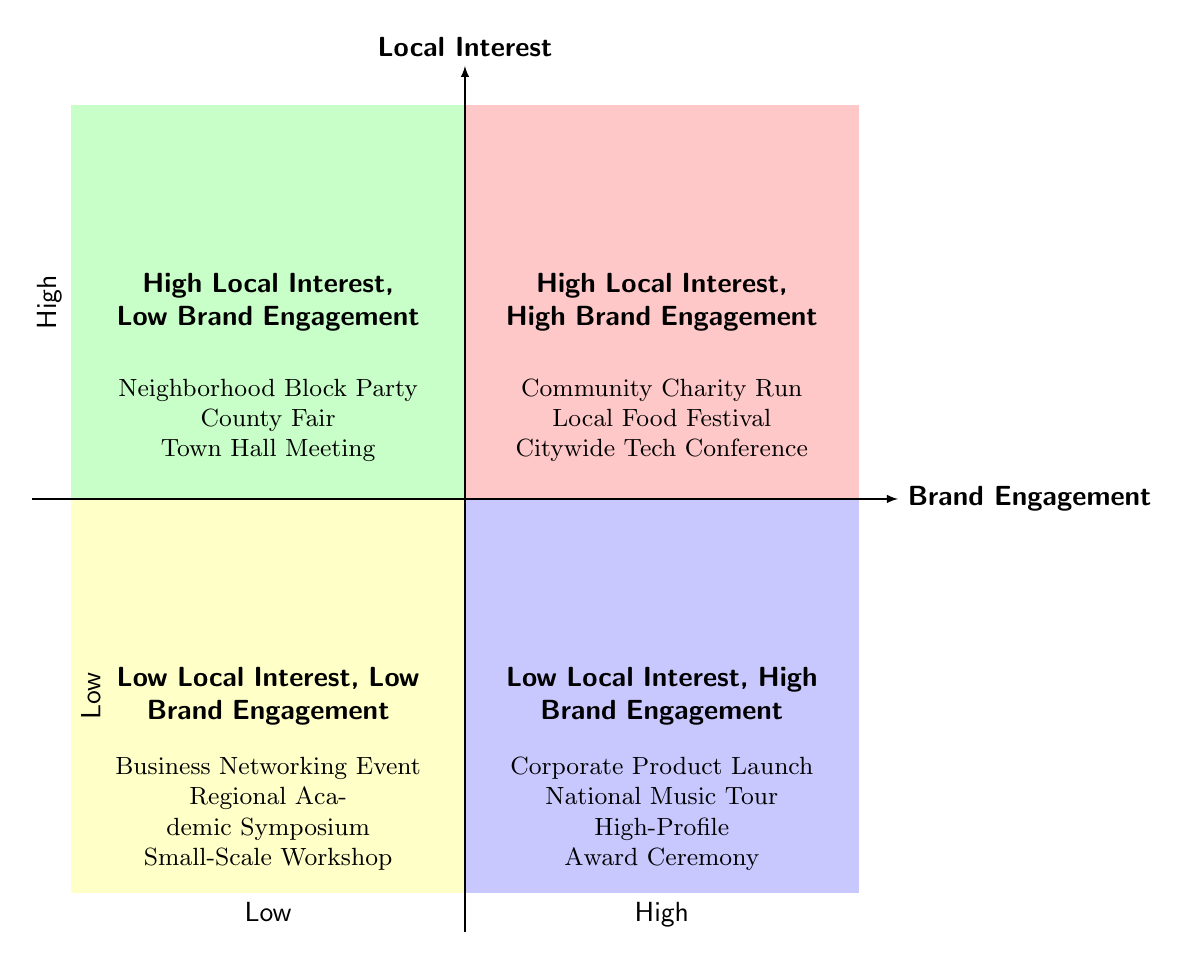What are examples in the "High Local Interest, High Brand Engagement" quadrant? The "High Local Interest, High Brand Engagement" quadrant includes examples like the Community Charity Run, Local Food Festival, and Citywide Tech Conference.
Answer: Community Charity Run, Local Food Festival, Citywide Tech Conference Which quadrant includes "Town Hall Meeting"? "Town Hall Meeting" is listed in the "High Local Interest, Low Brand Engagement" quadrant, indicating it has significant local interest but less brand engagement.
Answer: High Local Interest, Low Brand Engagement How many quadrants are shown in the diagram? The diagram features a total of four quadrants, each representing different levels of local interest and brand engagement.
Answer: Four Which event type is found in the "Low Local Interest, High Brand Engagement" quadrant? The "Low Local Interest, High Brand Engagement" quadrant includes examples like Corporate Product Launch, National Music Tour, and High-Profile Award Ceremony.
Answer: Corporate Product Launch, National Music Tour, High-Profile Award Ceremony What is indicated by the "Low Local Interest, Low Brand Engagement" quadrant? This quadrant represents events that do not generate significant local interest or brand engagement, such as Business Networking Event, Regional Academic Symposium, and Small-Scale Workshop.
Answer: Business Networking Event, Regional Academic Symposium, Small-Scale Workshop What is the relationship between "High Local Interest" and "Low Brand Engagement"? Events that are categorized as "High Local Interest, Low Brand Engagement" indicate that they attract local attendees but do not significantly promote the brand.
Answer: Events attract local attendees but do not significantly promote the brand Which quadrant would you focus on for maximum brand visibility? The best quadrant for maximizing brand visibility would be "High Local Interest, High Brand Engagement" as it combines both high local engagement with a strong brand presence.
Answer: High Local Interest, High Brand Engagement What color represents the "Low Local Interest, High Brand Engagement" quadrant? The "Low Local Interest, High Brand Engagement" quadrant is represented by a light blue color in the diagram.
Answer: Light blue Which events might struggle with brand visibility based on local interest? Events like the Neighborhood Block Party, County Fair, and Town Hall Meeting may struggle with brand visibility due to high local interest but low brand engagement.
Answer: Neighborhood Block Party, County Fair, Town Hall Meeting 